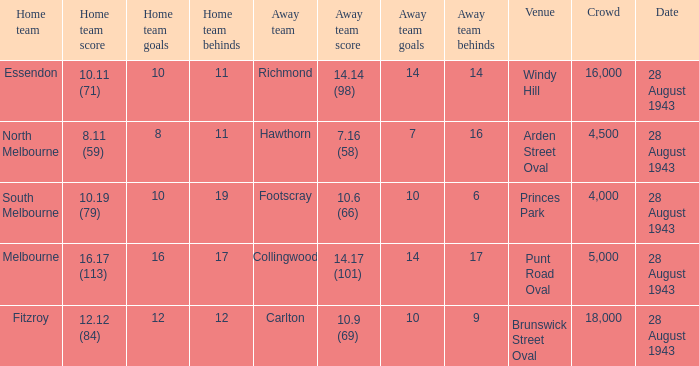What game showed a home team score of 8.11 (59)? 28 August 1943. 